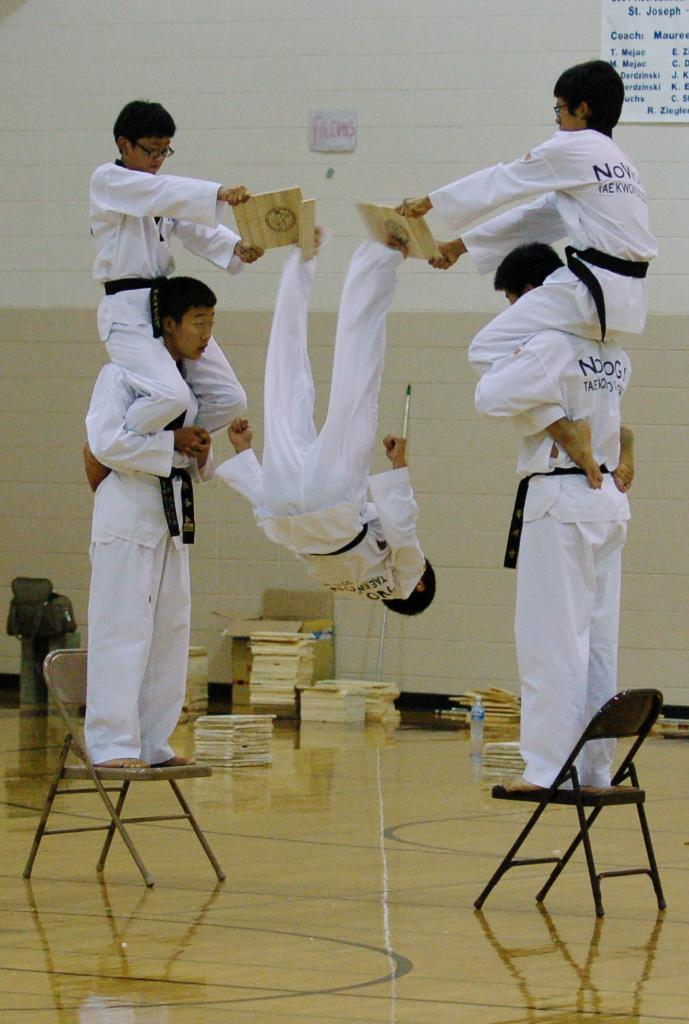What are the people in the image doing while standing on chairs? The people in the image are doing martial arts while standing on chairs. What can be seen in the background of the image? There is a wall in the background of the image. What is on the wall in the image? There are posters on the wall. Can you see a mountain in the image? No, there is no mountain present in the image. What type of bell is being rung in the image? There is no bell present in the image. 